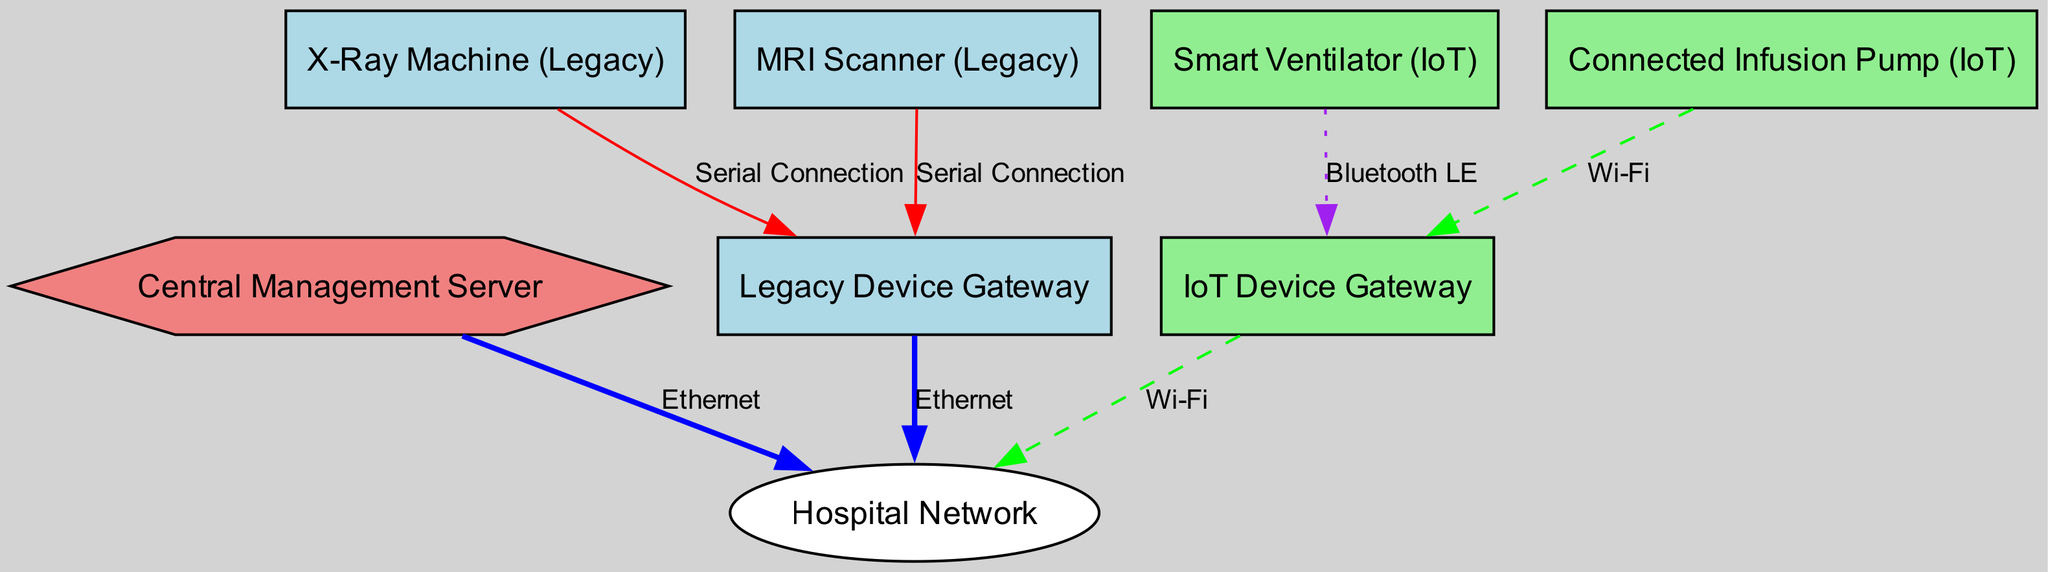What is the total number of nodes in the diagram? The diagram contains eight nodes: "Central Management Server," "Legacy Device Gateway," "IoT Device Gateway," "X-Ray Machine (Legacy)," "MRI Scanner (Legacy)," "Smart Ventilator (IoT)," "Connected Infusion Pump (IoT)," and "Hospital Network."
Answer: 8 What type of connection is used between the X-Ray Machine and the Legacy Device Gateway? The diagram indicates a "Serial Connection" between the X-Ray Machine and the Legacy Device Gateway, shown with an edge that connects these two nodes.
Answer: Serial Connection Which device connects to the IoT Device Gateway using Bluetooth? The "Smart Ventilator (IoT)" connects to the IoT Device Gateway via a "Bluetooth LE" connection, as depicted by the directed edge in the diagram.
Answer: Smart Ventilator (IoT) How many gateways are shown in the diagram? There are two gateways: the "Legacy Device Gateway" and the "IoT Device Gateway." This information can be confirmed by counting the two gateway nodes in the diagram.
Answer: 2 What is the color of the node representing the Central Management Server? The "Central Management Server" is represented as a hexagon in light coral color according to the color schema used in the diagram for different node types.
Answer: Light Coral Which machine uses Wi-Fi to connect to the Hospital Network? The "Connected Infusion Pump (IoT)" connects to the Hospital Network via Wi-Fi, as indicated by the dashed edge connecting these two nodes in the diagram.
Answer: Connected Infusion Pump (IoT) Which node has the most connections based on the diagram? The "Hospital Network" node has connections from three different nodes: "Central Management Server," "Legacy Device Gateway," and "IoT Device Gateway," making it the node with the most connections.
Answer: Hospital Network In the diagram, how is communication established between the Central Management Server and the Hospital Network? The communication between the "Central Management Server" and the "Hospital Network" is established via an Ethernet connection, which is represented by a bold edge connecting these two nodes.
Answer: Ethernet 